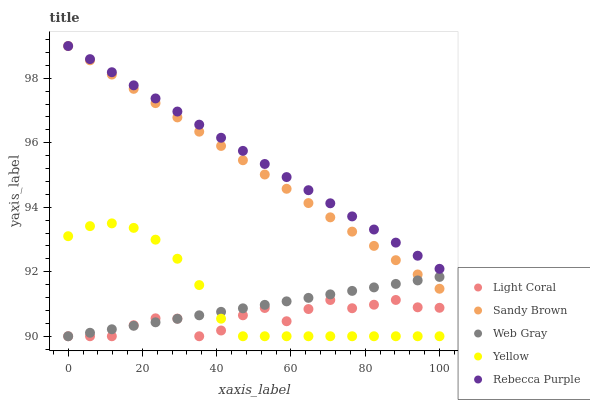Does Light Coral have the minimum area under the curve?
Answer yes or no. Yes. Does Rebecca Purple have the maximum area under the curve?
Answer yes or no. Yes. Does Web Gray have the minimum area under the curve?
Answer yes or no. No. Does Web Gray have the maximum area under the curve?
Answer yes or no. No. Is Rebecca Purple the smoothest?
Answer yes or no. Yes. Is Light Coral the roughest?
Answer yes or no. Yes. Is Web Gray the smoothest?
Answer yes or no. No. Is Web Gray the roughest?
Answer yes or no. No. Does Light Coral have the lowest value?
Answer yes or no. Yes. Does Sandy Brown have the lowest value?
Answer yes or no. No. Does Rebecca Purple have the highest value?
Answer yes or no. Yes. Does Web Gray have the highest value?
Answer yes or no. No. Is Web Gray less than Rebecca Purple?
Answer yes or no. Yes. Is Sandy Brown greater than Light Coral?
Answer yes or no. Yes. Does Web Gray intersect Light Coral?
Answer yes or no. Yes. Is Web Gray less than Light Coral?
Answer yes or no. No. Is Web Gray greater than Light Coral?
Answer yes or no. No. Does Web Gray intersect Rebecca Purple?
Answer yes or no. No. 